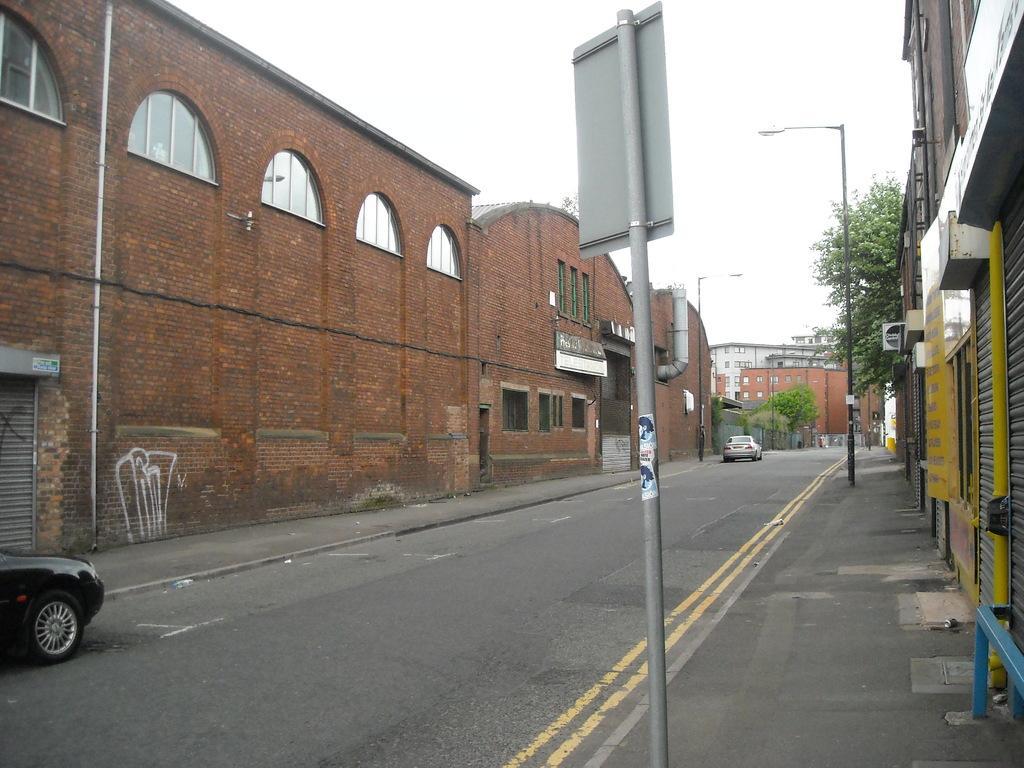How would you summarize this image in a sentence or two? In this image there are buildings and trees. We can see poles. At the bottom there is a road and we can see cars on the road. In the background there is sky. 